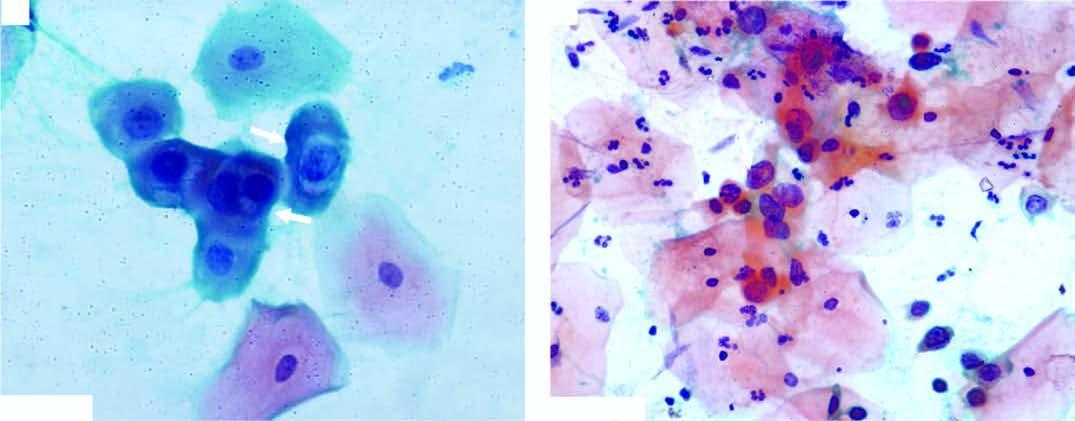do the squamous cells have scanty cytoplasm and markedly hyperchromatic nuclei having irregular nuclear outlines?
Answer the question using a single word or phrase. Yes 